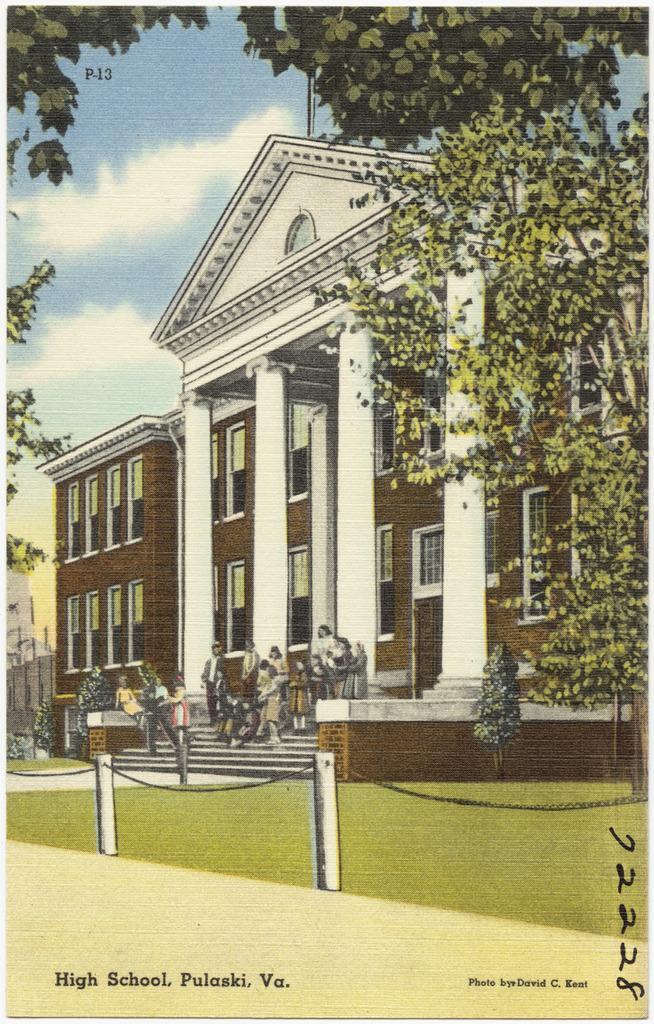In one or two sentences, can you explain what this image depicts? In this image we can see a sketch of building and few people standing on the stairs in front of the building, there are few trees, rods with chains and the sky with clouds in the background. 